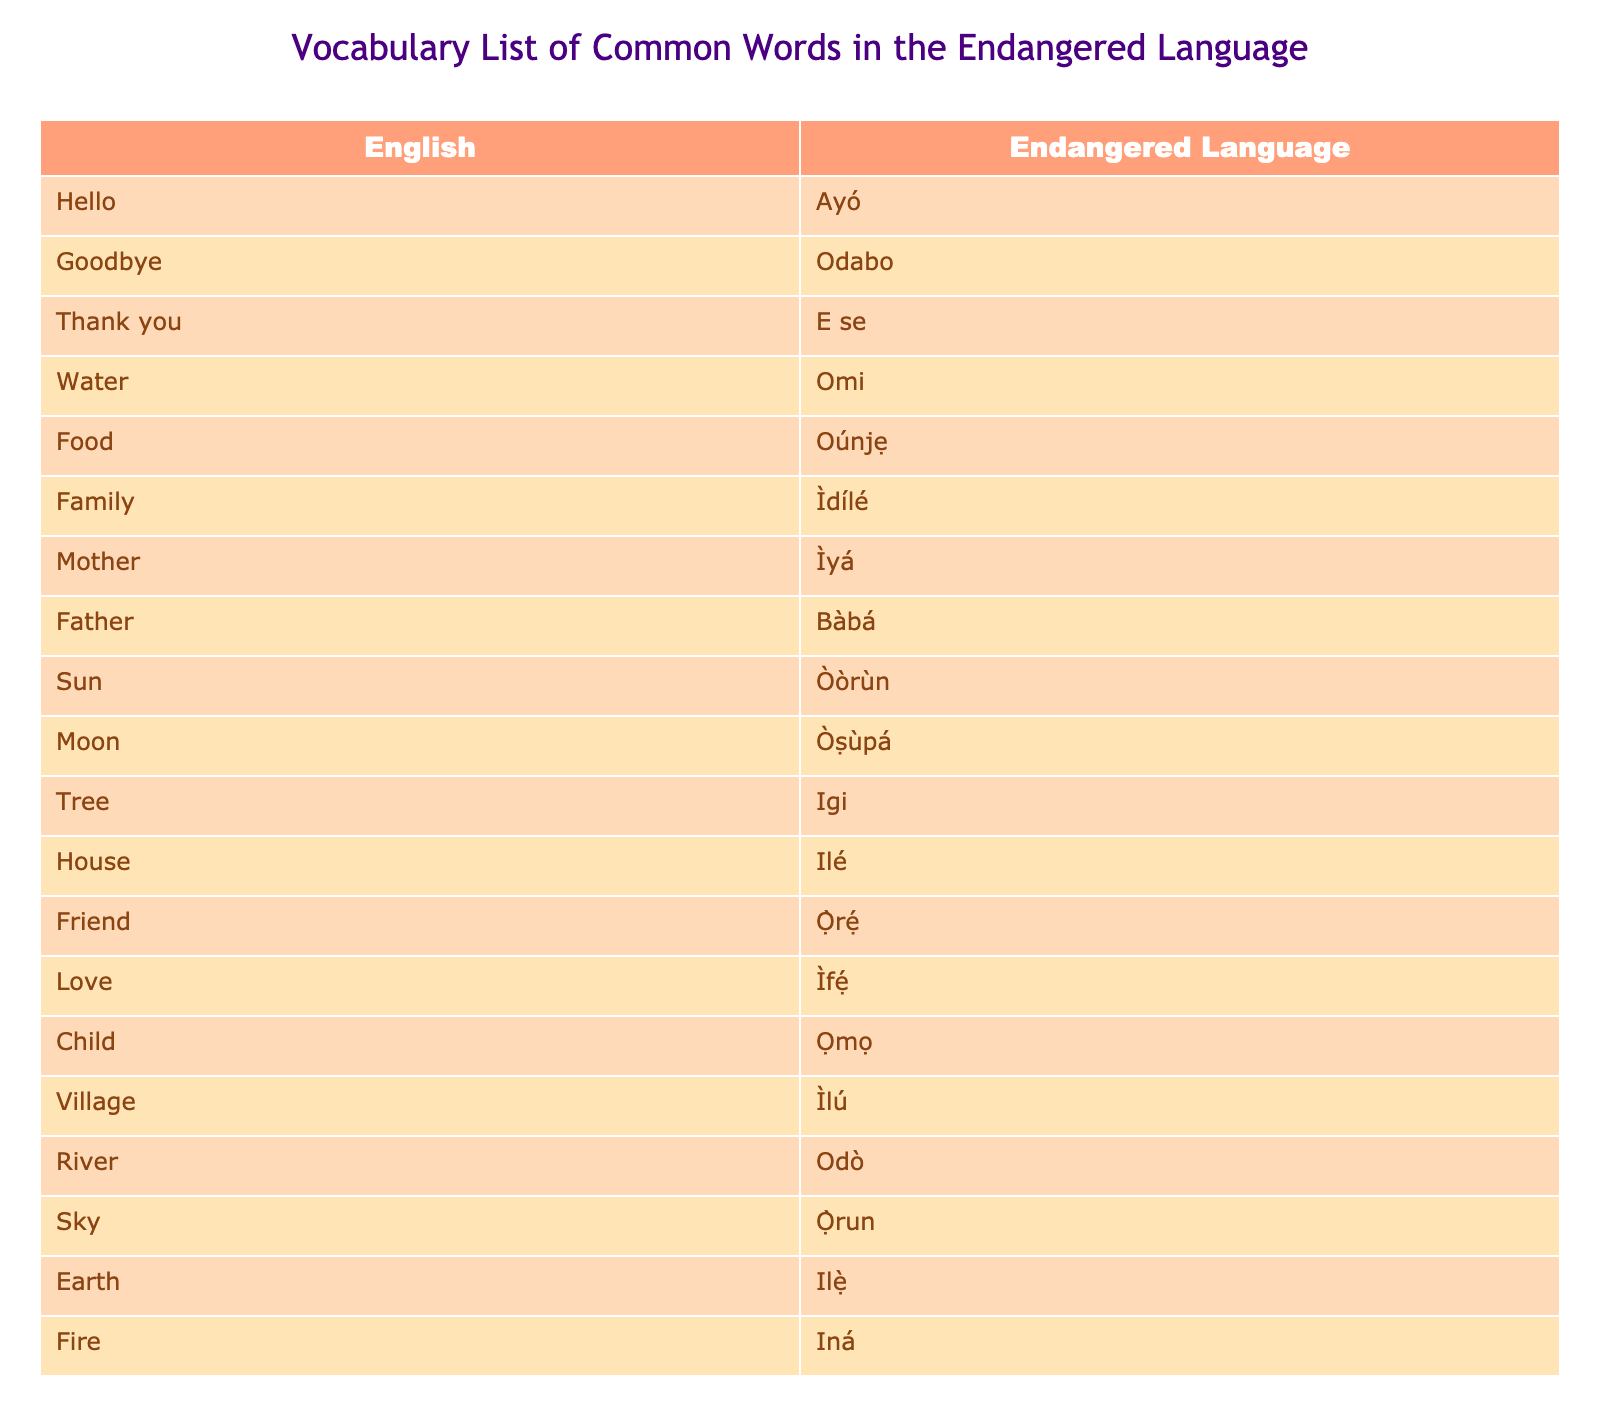What is the word for "Water" in the endangered language? The table lists English words alongside their translations in the endangered language. To find the translation for "Water," I look under the English column and find the corresponding row, which shows that it is "Omi."
Answer: Omi How do you say "Thank you" in the endangered language? By scanning the English column in the table, I find the word "Thank you" and look at its corresponding translation, which is "E se."
Answer: E se Is the word for "Mother" in the endangered language "Ìyá"? I check the row for "Mother" under the English column in the table and see that it translates to "Ìyá," so the statement is true.
Answer: Yes What is the translation for the word "Village"? I locate the English word "Village" in the table and find its corresponding translation is "Ìlú."
Answer: Ìlú What are the translations for "Sun" and "Moon"? The table lists "Sun" with the translation "Òòrùn" and "Moon" with "Òṣùpá." Both translations can be found in their respective rows directly from the table.
Answer: Òòrùn and Òṣùpá How many words in the table start with the letter 'O'? I count the entries in the table starting with 'O,' which are "Omi," "Odabo," "Oúnjẹ," "Ọ̀rẹ́," "Ọmọ," "Odò," and "Òòrùn," totaling 7 words.
Answer: 7 Which word has the longest translation in the endangered language? I review each translation's length in the table to find the longest one. "Ìdílé" has 6 characters, whereas "Òṣùpá," "Ilé," and "Ó̀rẹ́" have fewer characters. The longest word is therefore "Ìdílé."
Answer: Ìdílé Does the endangered language include words for natural elements like "Sky" and "Earth"? By examining the table, I see that "Sky" translates to "Ọ̀run" and "Earth" translates to "Ilẹ̀", confirming both are included.
Answer: Yes What is the relationship between "Father" and "Mother" in the table translations? I look at the translations where "Father" is "Bàbá" and "Mother" is "Ìyá." This shows that both have distinct words but represent parental roles.
Answer: Distinct words representing parental roles 